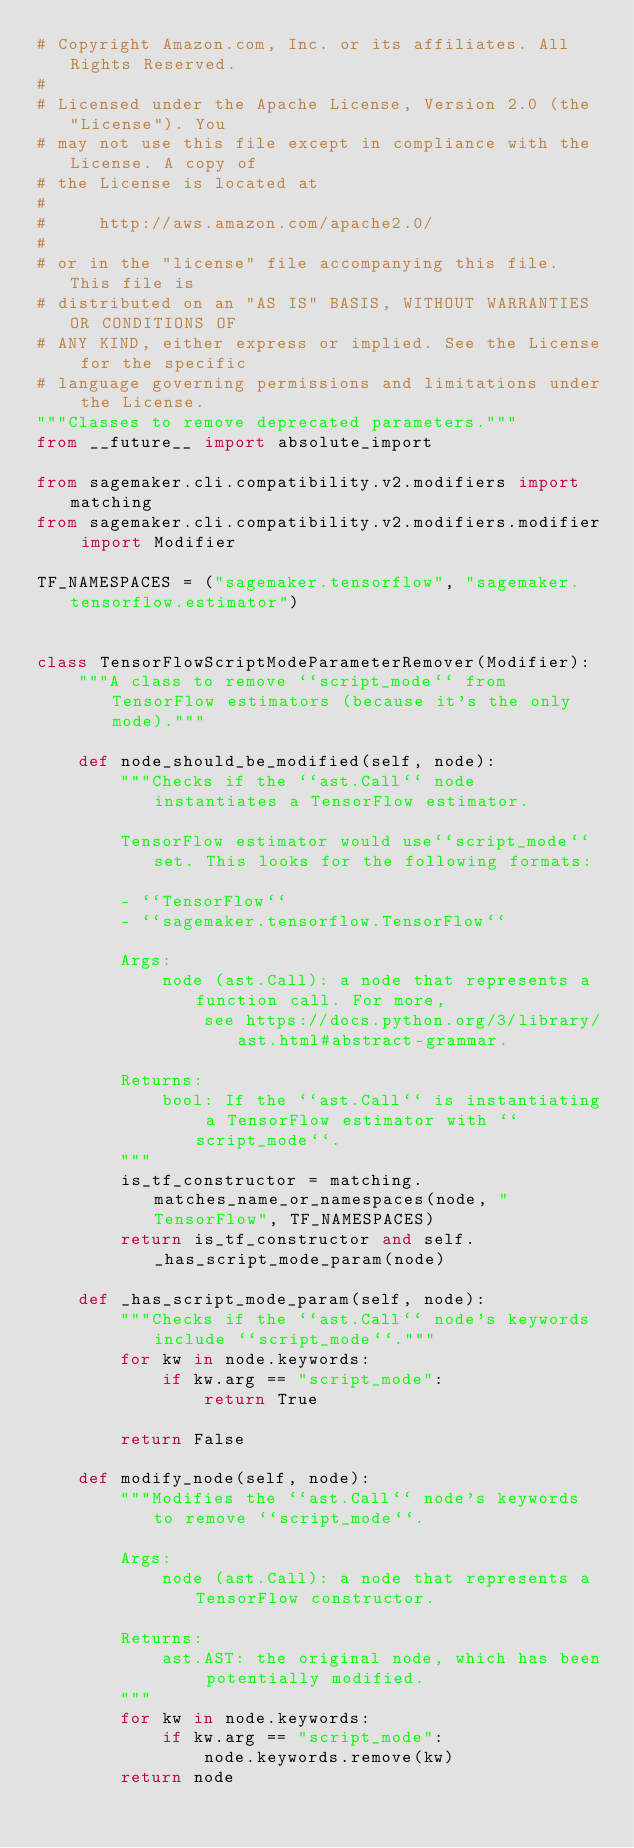Convert code to text. <code><loc_0><loc_0><loc_500><loc_500><_Python_># Copyright Amazon.com, Inc. or its affiliates. All Rights Reserved.
#
# Licensed under the Apache License, Version 2.0 (the "License"). You
# may not use this file except in compliance with the License. A copy of
# the License is located at
#
#     http://aws.amazon.com/apache2.0/
#
# or in the "license" file accompanying this file. This file is
# distributed on an "AS IS" BASIS, WITHOUT WARRANTIES OR CONDITIONS OF
# ANY KIND, either express or implied. See the License for the specific
# language governing permissions and limitations under the License.
"""Classes to remove deprecated parameters."""
from __future__ import absolute_import

from sagemaker.cli.compatibility.v2.modifiers import matching
from sagemaker.cli.compatibility.v2.modifiers.modifier import Modifier

TF_NAMESPACES = ("sagemaker.tensorflow", "sagemaker.tensorflow.estimator")


class TensorFlowScriptModeParameterRemover(Modifier):
    """A class to remove ``script_mode`` from TensorFlow estimators (because it's the only mode)."""

    def node_should_be_modified(self, node):
        """Checks if the ``ast.Call`` node instantiates a TensorFlow estimator.

        TensorFlow estimator would use``script_mode`` set. This looks for the following formats:

        - ``TensorFlow``
        - ``sagemaker.tensorflow.TensorFlow``

        Args:
            node (ast.Call): a node that represents a function call. For more,
                see https://docs.python.org/3/library/ast.html#abstract-grammar.

        Returns:
            bool: If the ``ast.Call`` is instantiating a TensorFlow estimator with ``script_mode``.
        """
        is_tf_constructor = matching.matches_name_or_namespaces(node, "TensorFlow", TF_NAMESPACES)
        return is_tf_constructor and self._has_script_mode_param(node)

    def _has_script_mode_param(self, node):
        """Checks if the ``ast.Call`` node's keywords include ``script_mode``."""
        for kw in node.keywords:
            if kw.arg == "script_mode":
                return True

        return False

    def modify_node(self, node):
        """Modifies the ``ast.Call`` node's keywords to remove ``script_mode``.

        Args:
            node (ast.Call): a node that represents a TensorFlow constructor.

        Returns:
            ast.AST: the original node, which has been potentially modified.
        """
        for kw in node.keywords:
            if kw.arg == "script_mode":
                node.keywords.remove(kw)
        return node
</code> 